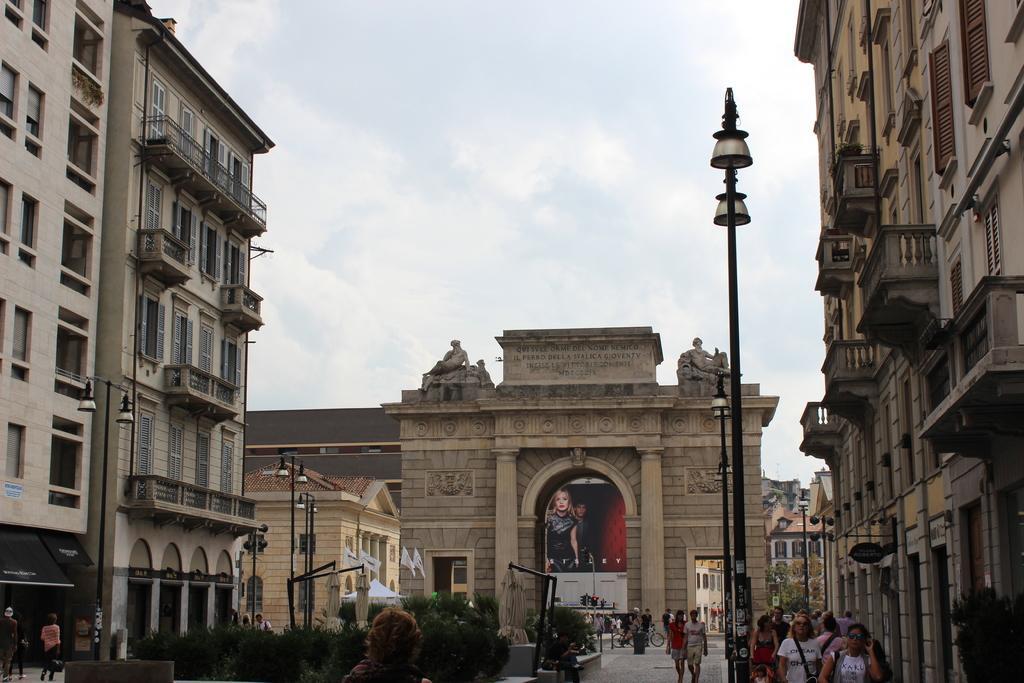Could you give a brief overview of what you see in this image? In the picture I can see people are walking on the ground. In the background I can see buildings, street lights, plants, the sky and some other objects on the ground. 